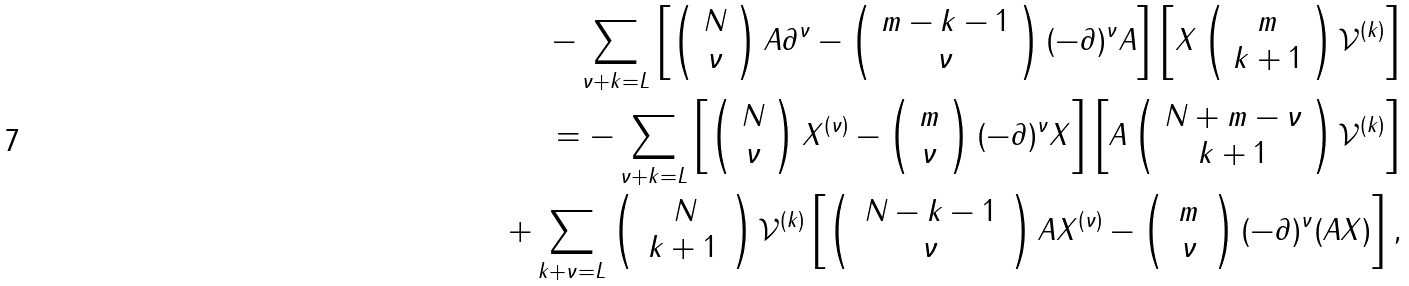Convert formula to latex. <formula><loc_0><loc_0><loc_500><loc_500>- \sum _ { \nu + k = L } \left [ \left ( \begin{array} { c } N \\ \nu \end{array} \right ) A \partial ^ { \nu } - \left ( \begin{array} { c } m - k - 1 \\ \nu \end{array} \right ) ( - \partial ) ^ { \nu } A \right ] \left [ X \left ( \begin{array} { c } m \\ k + 1 \end{array} \right ) { \mathcal { V } } ^ { ( k ) } \right ] \\ = - \sum _ { \nu + k = L } \left [ \left ( \begin{array} { c } N \\ \nu \end{array} \right ) X ^ { ( \nu ) } - \left ( \begin{array} { c } m \\ \nu \end{array} \right ) ( - \partial ) ^ { \nu } X \right ] \left [ A \left ( \begin{array} { c } N + m - \nu \\ k + 1 \end{array} \right ) { \mathcal { V } } ^ { ( k ) } \right ] \\ + \sum _ { k + \nu = L } \left ( \, \begin{array} { c } N \\ k + 1 \, \end{array} \right ) { \mathcal { V } } ^ { ( k ) } \left [ \left ( \, \begin{array} { c } N - k - 1 \\ \nu \end{array} \, \right ) A X ^ { ( \nu ) } - \left ( \, \begin{array} { c } m \\ \nu \end{array} \, \right ) ( - \partial ) ^ { \nu } ( A X ) \right ] ,</formula> 